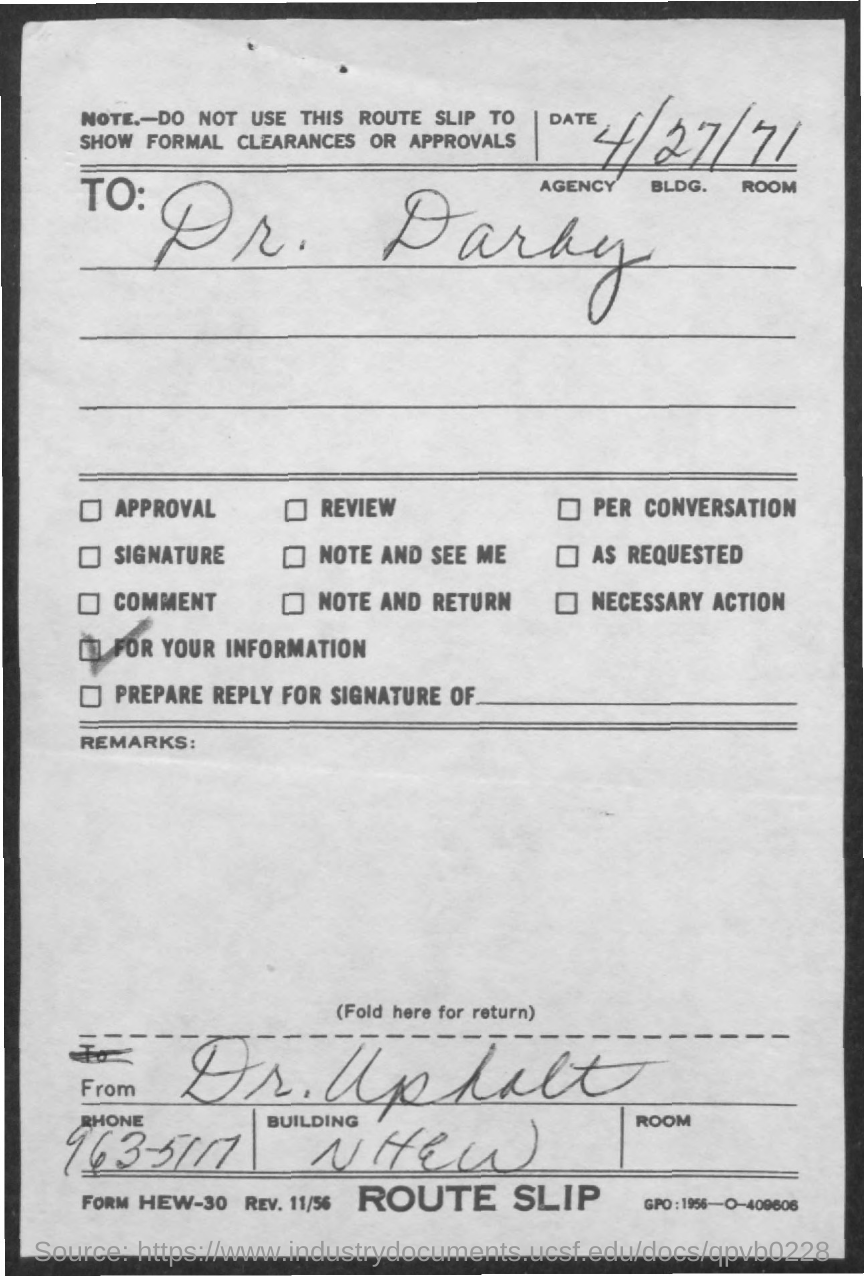Give some essential details in this illustration. The route slip was given to whom? Dr. Darby. The phone number listed on the given slip is 963-5117... 